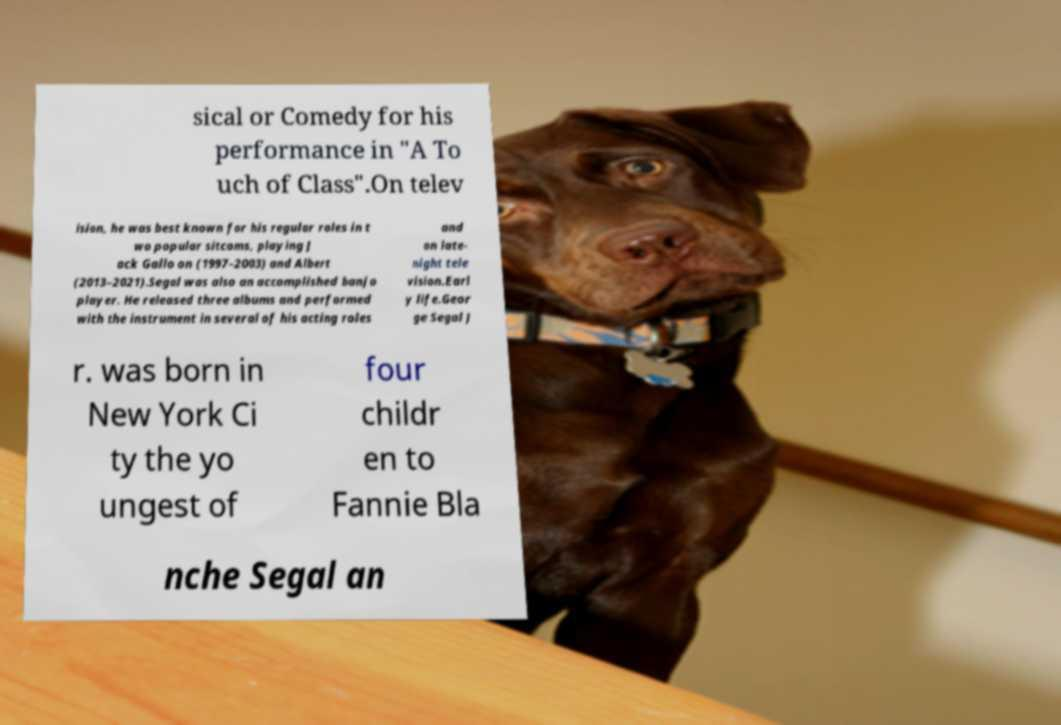Could you assist in decoding the text presented in this image and type it out clearly? sical or Comedy for his performance in "A To uch of Class".On telev ision, he was best known for his regular roles in t wo popular sitcoms, playing J ack Gallo on (1997–2003) and Albert (2013–2021).Segal was also an accomplished banjo player. He released three albums and performed with the instrument in several of his acting roles and on late- night tele vision.Earl y life.Geor ge Segal J r. was born in New York Ci ty the yo ungest of four childr en to Fannie Bla nche Segal an 